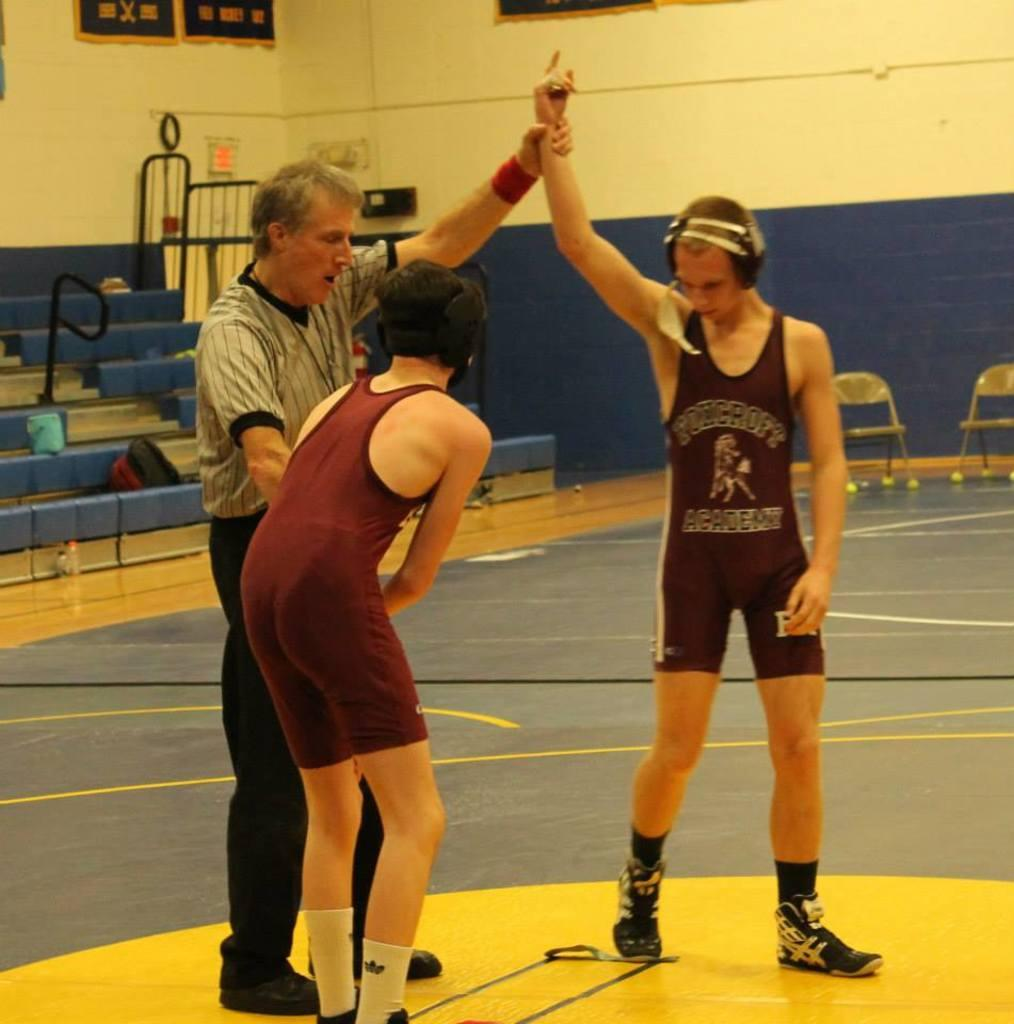<image>
Summarize the visual content of the image. Two wrestlers stand next to a referee in maroon jerseys that say PONCROFT ACADEMY 